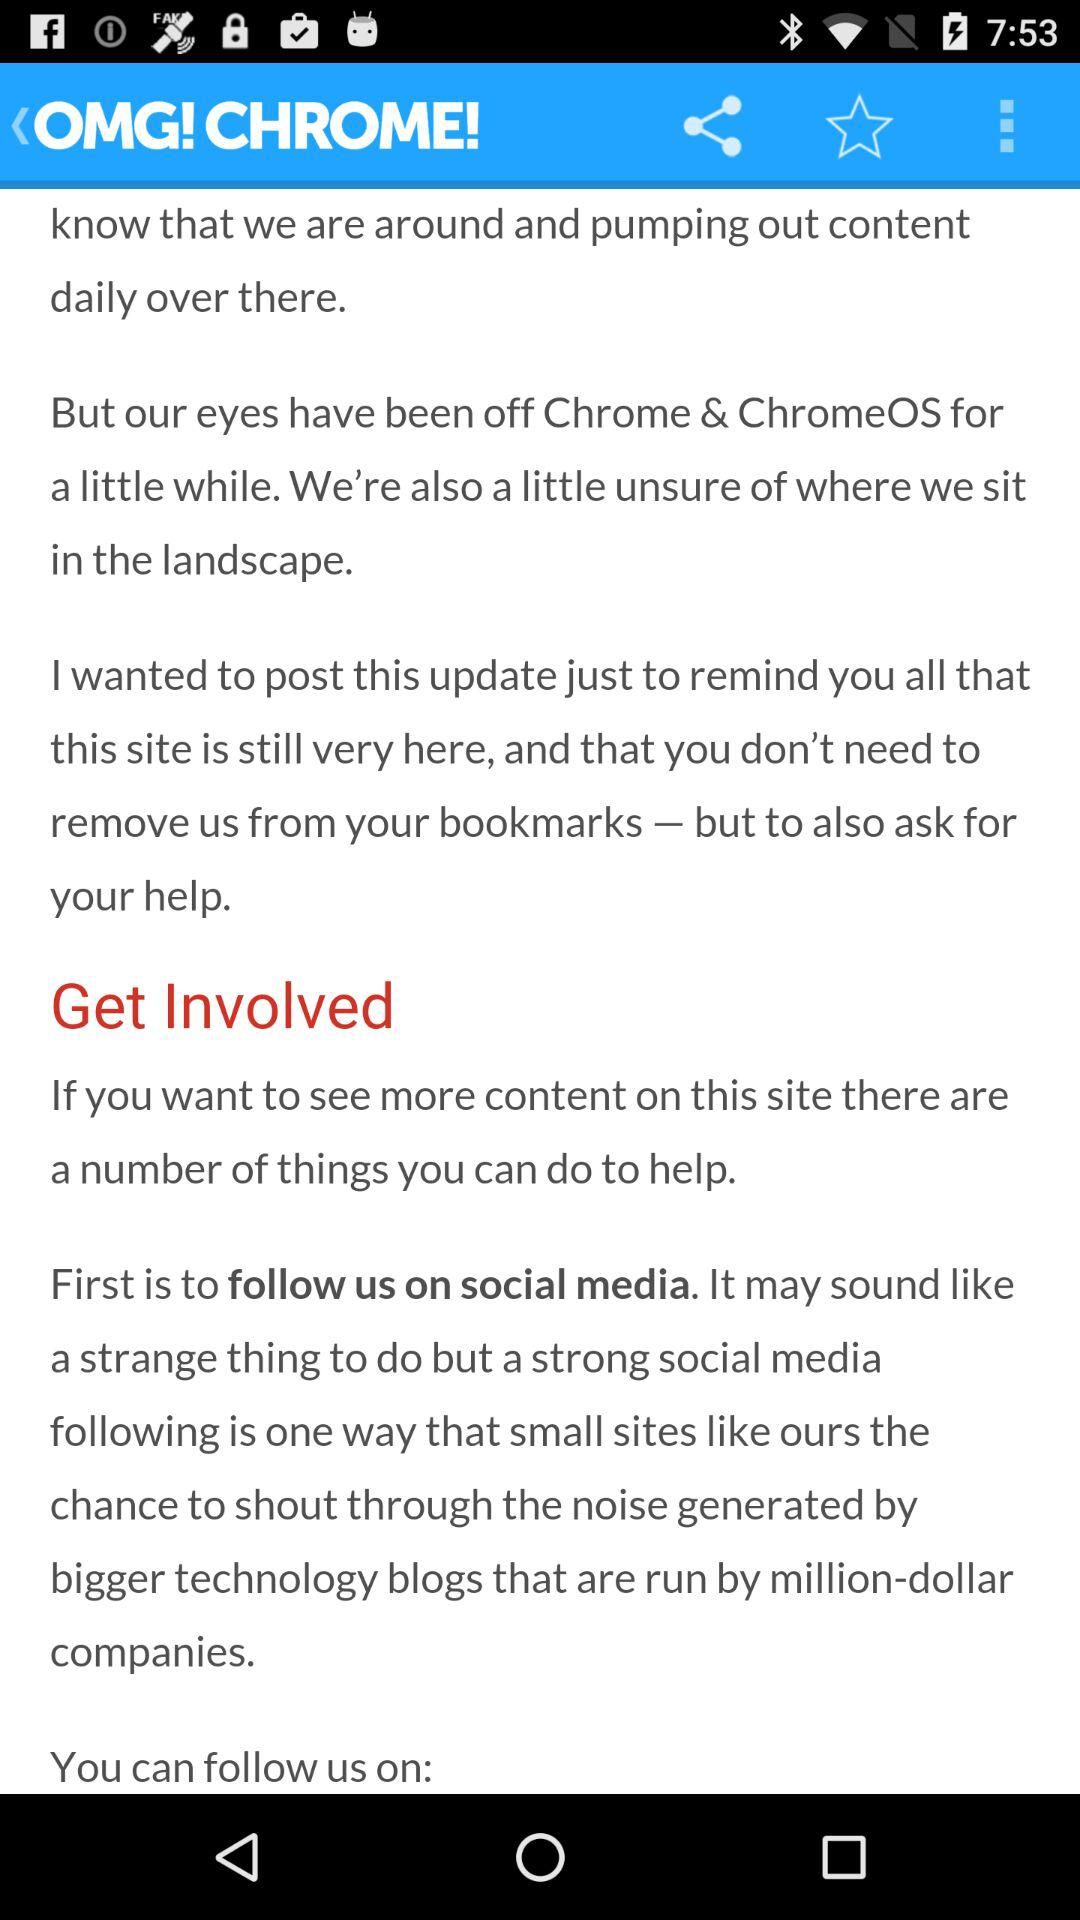What is the name of the application? The name of the application is "OMG! CHROME!". 